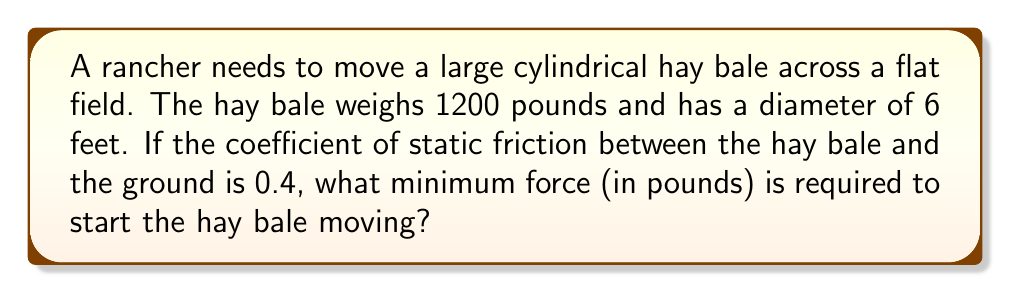Solve this math problem. To solve this problem, we'll use the concept of static friction and Newton's Second Law. Here's a step-by-step approach:

1. Identify the forces acting on the hay bale:
   - Weight (W) acting downward
   - Normal force (N) acting upward from the ground
   - Static friction force (f) acting opposite to the direction of motion
   - Applied force (F) needed to move the bale

2. The weight of the hay bale is given:
   $W = 1200 \text{ lbs}$

3. Since the bale is on a flat surface, the normal force is equal to the weight:
   $N = W = 1200 \text{ lbs}$

4. The maximum static friction force is given by:
   $f_{\text{max}} = \mu_s N$
   where $\mu_s$ is the coefficient of static friction

5. Calculate the maximum static friction:
   $f_{\text{max}} = 0.4 \times 1200 = 480 \text{ lbs}$

6. To start moving the bale, the applied force must be greater than the maximum static friction:
   $F > f_{\text{max}}$

7. The minimum force required is just slightly more than the maximum static friction:
   $F_{\text{min}} = f_{\text{max}} = 480 \text{ lbs}$

Therefore, the minimum force required to start moving the hay bale is 480 pounds.
Answer: 480 lbs 